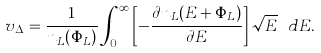Convert formula to latex. <formula><loc_0><loc_0><loc_500><loc_500>v _ { \Delta } = \frac { 1 } { n _ { L } ( \Phi _ { L } ) } \int _ { 0 } ^ { \infty } \left [ - \frac { \partial n _ { L } ( E + \Phi _ { L } ) } { \partial E } \right ] \sqrt { E } \ d E .</formula> 